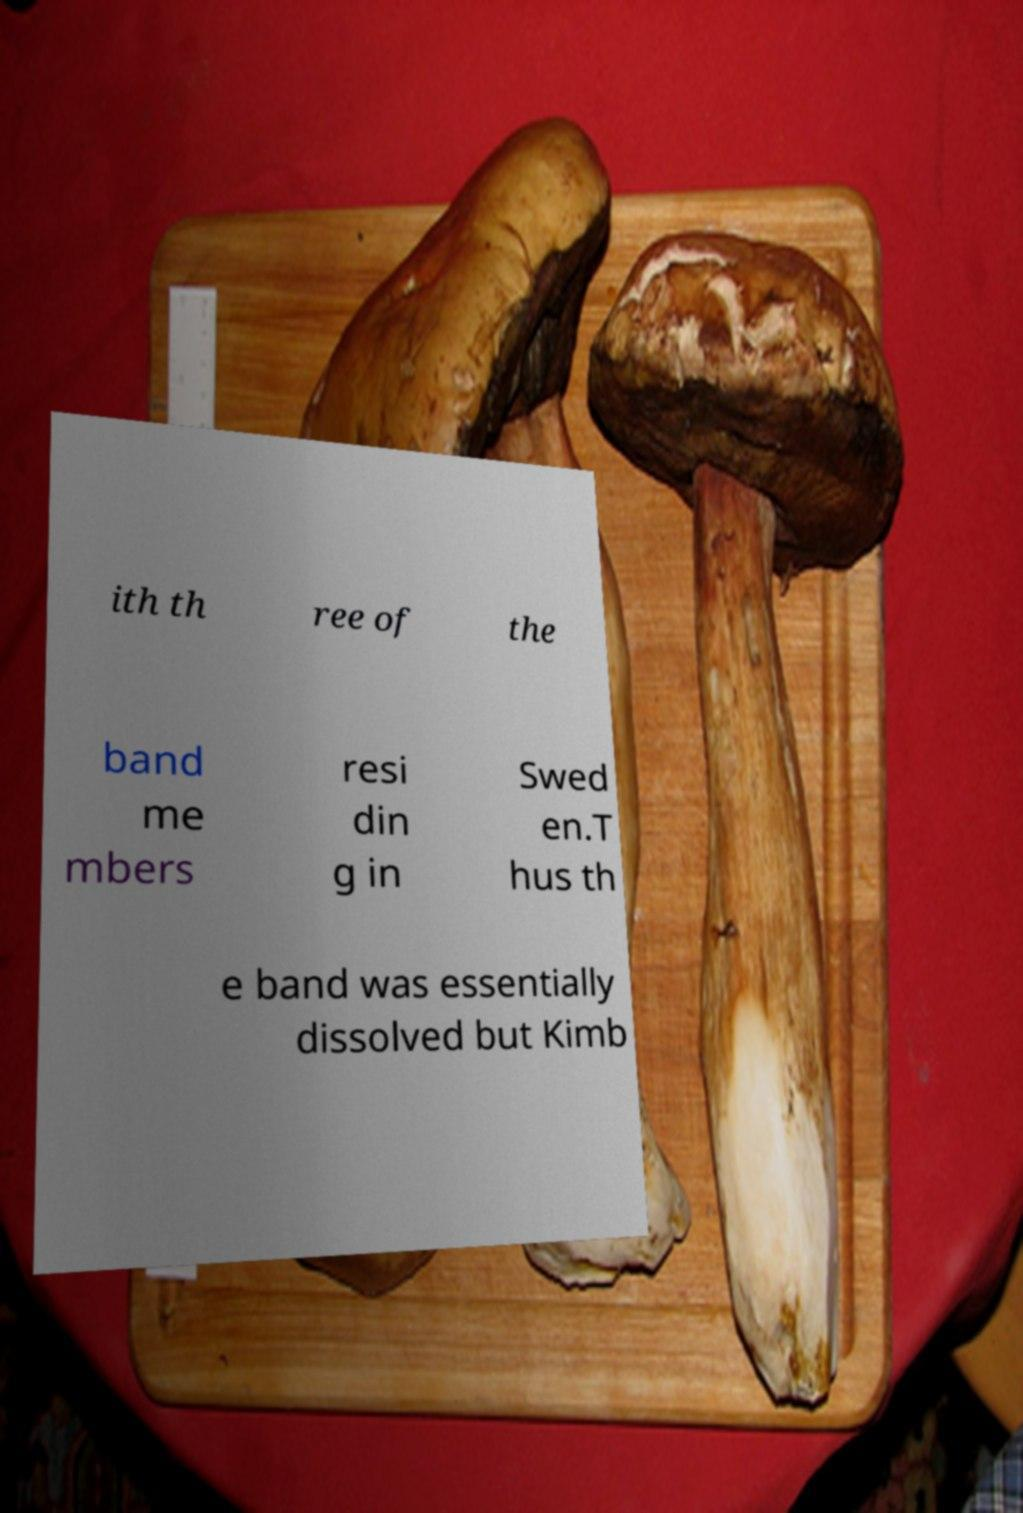Please read and relay the text visible in this image. What does it say? ith th ree of the band me mbers resi din g in Swed en.T hus th e band was essentially dissolved but Kimb 